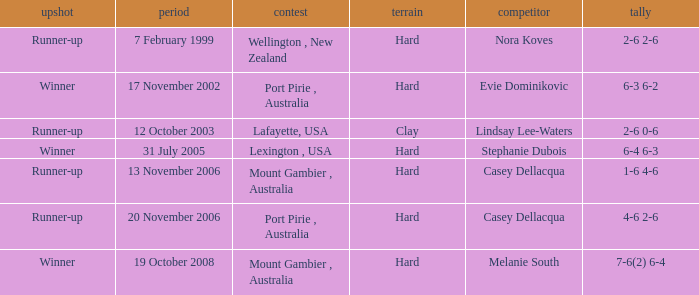Which Opponent is on 17 november 2002? Evie Dominikovic. 